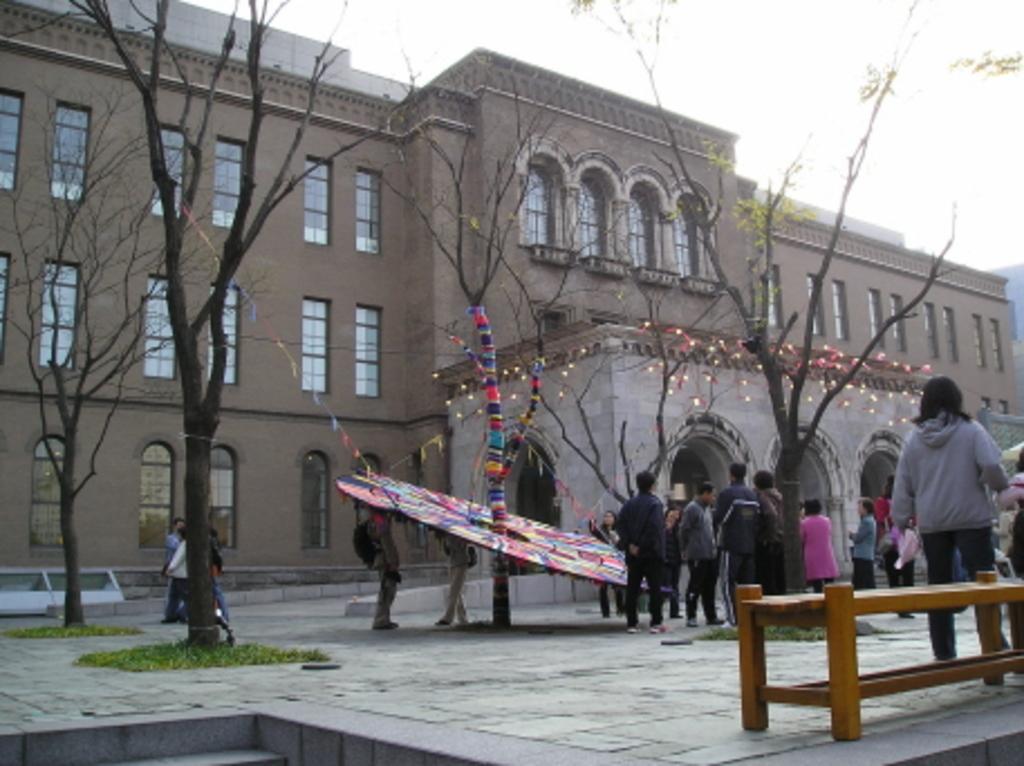Could you give a brief overview of what you see in this image? In this image we have building and a few trees in front of it. Here we have a group of people who are standing on the ground and in front of the image we have a bench. 